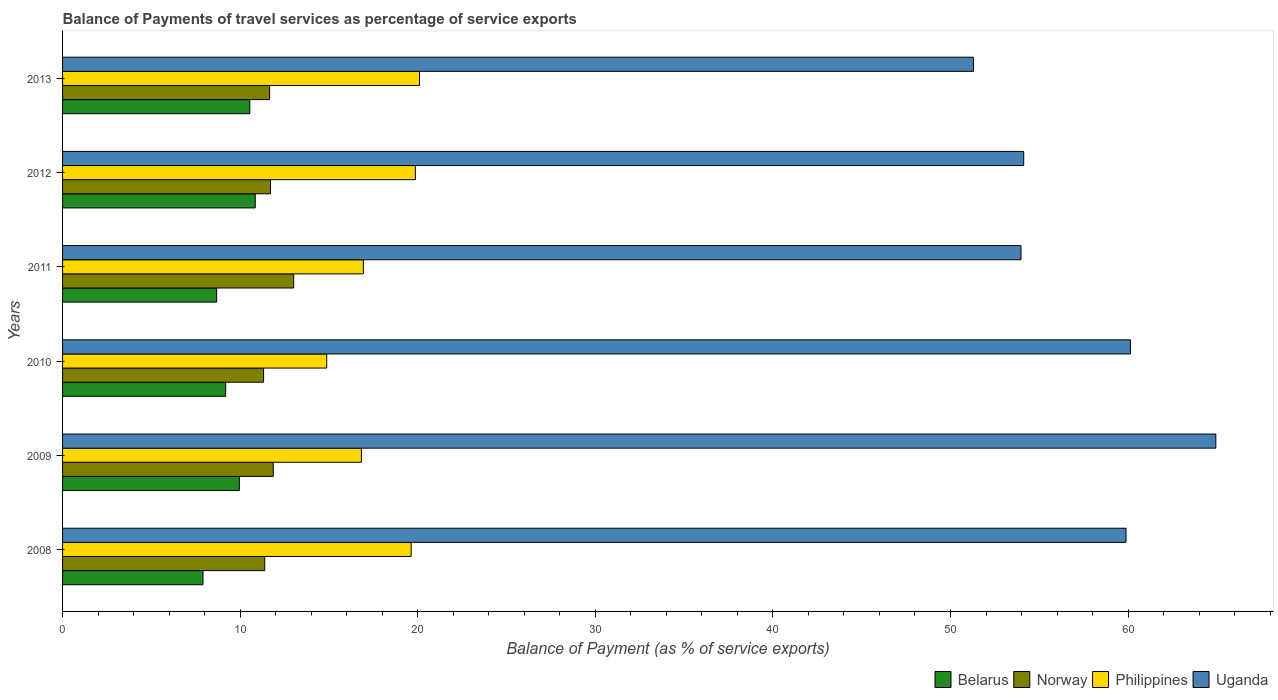Are the number of bars on each tick of the Y-axis equal?
Ensure brevity in your answer.  Yes. In how many cases, is the number of bars for a given year not equal to the number of legend labels?
Your answer should be compact. 0. What is the balance of payments of travel services in Belarus in 2012?
Keep it short and to the point. 10.85. Across all years, what is the maximum balance of payments of travel services in Uganda?
Offer a very short reply. 64.94. Across all years, what is the minimum balance of payments of travel services in Philippines?
Make the answer very short. 14.87. In which year was the balance of payments of travel services in Norway maximum?
Make the answer very short. 2011. In which year was the balance of payments of travel services in Uganda minimum?
Provide a succinct answer. 2013. What is the total balance of payments of travel services in Uganda in the graph?
Your answer should be compact. 344.34. What is the difference between the balance of payments of travel services in Uganda in 2008 and that in 2011?
Offer a terse response. 5.91. What is the difference between the balance of payments of travel services in Belarus in 2010 and the balance of payments of travel services in Norway in 2008?
Provide a succinct answer. -2.2. What is the average balance of payments of travel services in Belarus per year?
Your answer should be compact. 9.52. In the year 2011, what is the difference between the balance of payments of travel services in Norway and balance of payments of travel services in Uganda?
Make the answer very short. -40.96. In how many years, is the balance of payments of travel services in Belarus greater than 50 %?
Make the answer very short. 0. What is the ratio of the balance of payments of travel services in Philippines in 2008 to that in 2009?
Keep it short and to the point. 1.17. Is the difference between the balance of payments of travel services in Norway in 2011 and 2012 greater than the difference between the balance of payments of travel services in Uganda in 2011 and 2012?
Offer a terse response. Yes. What is the difference between the highest and the second highest balance of payments of travel services in Uganda?
Offer a very short reply. 4.81. What is the difference between the highest and the lowest balance of payments of travel services in Uganda?
Your response must be concise. 13.65. Is it the case that in every year, the sum of the balance of payments of travel services in Belarus and balance of payments of travel services in Norway is greater than the sum of balance of payments of travel services in Uganda and balance of payments of travel services in Philippines?
Your response must be concise. No. What does the 1st bar from the top in 2013 represents?
Ensure brevity in your answer.  Uganda. Is it the case that in every year, the sum of the balance of payments of travel services in Norway and balance of payments of travel services in Belarus is greater than the balance of payments of travel services in Uganda?
Give a very brief answer. No. Are all the bars in the graph horizontal?
Give a very brief answer. Yes. How many years are there in the graph?
Keep it short and to the point. 6. Does the graph contain any zero values?
Provide a succinct answer. No. How many legend labels are there?
Provide a succinct answer. 4. What is the title of the graph?
Make the answer very short. Balance of Payments of travel services as percentage of service exports. What is the label or title of the X-axis?
Make the answer very short. Balance of Payment (as % of service exports). What is the Balance of Payment (as % of service exports) of Belarus in 2008?
Your answer should be compact. 7.91. What is the Balance of Payment (as % of service exports) in Norway in 2008?
Provide a succinct answer. 11.38. What is the Balance of Payment (as % of service exports) of Philippines in 2008?
Ensure brevity in your answer.  19.63. What is the Balance of Payment (as % of service exports) in Uganda in 2008?
Make the answer very short. 59.88. What is the Balance of Payment (as % of service exports) in Belarus in 2009?
Ensure brevity in your answer.  9.95. What is the Balance of Payment (as % of service exports) of Norway in 2009?
Give a very brief answer. 11.86. What is the Balance of Payment (as % of service exports) in Philippines in 2009?
Give a very brief answer. 16.83. What is the Balance of Payment (as % of service exports) in Uganda in 2009?
Provide a succinct answer. 64.94. What is the Balance of Payment (as % of service exports) in Belarus in 2010?
Your answer should be compact. 9.18. What is the Balance of Payment (as % of service exports) of Norway in 2010?
Make the answer very short. 11.32. What is the Balance of Payment (as % of service exports) in Philippines in 2010?
Your answer should be compact. 14.87. What is the Balance of Payment (as % of service exports) of Uganda in 2010?
Give a very brief answer. 60.13. What is the Balance of Payment (as % of service exports) in Belarus in 2011?
Give a very brief answer. 8.68. What is the Balance of Payment (as % of service exports) of Norway in 2011?
Keep it short and to the point. 13.01. What is the Balance of Payment (as % of service exports) in Philippines in 2011?
Keep it short and to the point. 16.94. What is the Balance of Payment (as % of service exports) in Uganda in 2011?
Your response must be concise. 53.97. What is the Balance of Payment (as % of service exports) in Belarus in 2012?
Keep it short and to the point. 10.85. What is the Balance of Payment (as % of service exports) of Norway in 2012?
Your answer should be very brief. 11.71. What is the Balance of Payment (as % of service exports) in Philippines in 2012?
Provide a succinct answer. 19.87. What is the Balance of Payment (as % of service exports) of Uganda in 2012?
Your answer should be compact. 54.12. What is the Balance of Payment (as % of service exports) of Belarus in 2013?
Provide a succinct answer. 10.54. What is the Balance of Payment (as % of service exports) of Norway in 2013?
Provide a succinct answer. 11.66. What is the Balance of Payment (as % of service exports) in Philippines in 2013?
Keep it short and to the point. 20.1. What is the Balance of Payment (as % of service exports) of Uganda in 2013?
Give a very brief answer. 51.29. Across all years, what is the maximum Balance of Payment (as % of service exports) of Belarus?
Provide a short and direct response. 10.85. Across all years, what is the maximum Balance of Payment (as % of service exports) of Norway?
Your answer should be compact. 13.01. Across all years, what is the maximum Balance of Payment (as % of service exports) in Philippines?
Offer a very short reply. 20.1. Across all years, what is the maximum Balance of Payment (as % of service exports) in Uganda?
Your response must be concise. 64.94. Across all years, what is the minimum Balance of Payment (as % of service exports) of Belarus?
Provide a short and direct response. 7.91. Across all years, what is the minimum Balance of Payment (as % of service exports) of Norway?
Offer a terse response. 11.32. Across all years, what is the minimum Balance of Payment (as % of service exports) in Philippines?
Ensure brevity in your answer.  14.87. Across all years, what is the minimum Balance of Payment (as % of service exports) of Uganda?
Your answer should be compact. 51.29. What is the total Balance of Payment (as % of service exports) in Belarus in the graph?
Give a very brief answer. 57.11. What is the total Balance of Payment (as % of service exports) of Norway in the graph?
Your answer should be very brief. 70.95. What is the total Balance of Payment (as % of service exports) of Philippines in the graph?
Your answer should be compact. 108.23. What is the total Balance of Payment (as % of service exports) of Uganda in the graph?
Your answer should be compact. 344.34. What is the difference between the Balance of Payment (as % of service exports) of Belarus in 2008 and that in 2009?
Offer a terse response. -2.05. What is the difference between the Balance of Payment (as % of service exports) of Norway in 2008 and that in 2009?
Offer a very short reply. -0.48. What is the difference between the Balance of Payment (as % of service exports) in Philippines in 2008 and that in 2009?
Offer a terse response. 2.8. What is the difference between the Balance of Payment (as % of service exports) of Uganda in 2008 and that in 2009?
Your response must be concise. -5.06. What is the difference between the Balance of Payment (as % of service exports) in Belarus in 2008 and that in 2010?
Offer a terse response. -1.28. What is the difference between the Balance of Payment (as % of service exports) in Norway in 2008 and that in 2010?
Make the answer very short. 0.07. What is the difference between the Balance of Payment (as % of service exports) of Philippines in 2008 and that in 2010?
Provide a short and direct response. 4.75. What is the difference between the Balance of Payment (as % of service exports) of Uganda in 2008 and that in 2010?
Keep it short and to the point. -0.25. What is the difference between the Balance of Payment (as % of service exports) in Belarus in 2008 and that in 2011?
Keep it short and to the point. -0.77. What is the difference between the Balance of Payment (as % of service exports) of Norway in 2008 and that in 2011?
Keep it short and to the point. -1.63. What is the difference between the Balance of Payment (as % of service exports) of Philippines in 2008 and that in 2011?
Your response must be concise. 2.69. What is the difference between the Balance of Payment (as % of service exports) in Uganda in 2008 and that in 2011?
Keep it short and to the point. 5.91. What is the difference between the Balance of Payment (as % of service exports) of Belarus in 2008 and that in 2012?
Ensure brevity in your answer.  -2.94. What is the difference between the Balance of Payment (as % of service exports) of Norway in 2008 and that in 2012?
Ensure brevity in your answer.  -0.33. What is the difference between the Balance of Payment (as % of service exports) in Philippines in 2008 and that in 2012?
Provide a short and direct response. -0.24. What is the difference between the Balance of Payment (as % of service exports) in Uganda in 2008 and that in 2012?
Offer a terse response. 5.76. What is the difference between the Balance of Payment (as % of service exports) of Belarus in 2008 and that in 2013?
Ensure brevity in your answer.  -2.64. What is the difference between the Balance of Payment (as % of service exports) in Norway in 2008 and that in 2013?
Make the answer very short. -0.27. What is the difference between the Balance of Payment (as % of service exports) in Philippines in 2008 and that in 2013?
Your answer should be compact. -0.47. What is the difference between the Balance of Payment (as % of service exports) in Uganda in 2008 and that in 2013?
Your response must be concise. 8.59. What is the difference between the Balance of Payment (as % of service exports) in Belarus in 2009 and that in 2010?
Offer a terse response. 0.77. What is the difference between the Balance of Payment (as % of service exports) of Norway in 2009 and that in 2010?
Your answer should be compact. 0.54. What is the difference between the Balance of Payment (as % of service exports) in Philippines in 2009 and that in 2010?
Ensure brevity in your answer.  1.95. What is the difference between the Balance of Payment (as % of service exports) in Uganda in 2009 and that in 2010?
Your answer should be compact. 4.81. What is the difference between the Balance of Payment (as % of service exports) in Belarus in 2009 and that in 2011?
Your answer should be compact. 1.28. What is the difference between the Balance of Payment (as % of service exports) of Norway in 2009 and that in 2011?
Your response must be concise. -1.15. What is the difference between the Balance of Payment (as % of service exports) in Philippines in 2009 and that in 2011?
Give a very brief answer. -0.11. What is the difference between the Balance of Payment (as % of service exports) of Uganda in 2009 and that in 2011?
Give a very brief answer. 10.97. What is the difference between the Balance of Payment (as % of service exports) in Belarus in 2009 and that in 2012?
Make the answer very short. -0.89. What is the difference between the Balance of Payment (as % of service exports) of Norway in 2009 and that in 2012?
Keep it short and to the point. 0.15. What is the difference between the Balance of Payment (as % of service exports) of Philippines in 2009 and that in 2012?
Ensure brevity in your answer.  -3.04. What is the difference between the Balance of Payment (as % of service exports) in Uganda in 2009 and that in 2012?
Your answer should be compact. 10.82. What is the difference between the Balance of Payment (as % of service exports) of Belarus in 2009 and that in 2013?
Offer a very short reply. -0.59. What is the difference between the Balance of Payment (as % of service exports) in Norway in 2009 and that in 2013?
Keep it short and to the point. 0.2. What is the difference between the Balance of Payment (as % of service exports) of Philippines in 2009 and that in 2013?
Offer a terse response. -3.27. What is the difference between the Balance of Payment (as % of service exports) of Uganda in 2009 and that in 2013?
Provide a succinct answer. 13.65. What is the difference between the Balance of Payment (as % of service exports) in Belarus in 2010 and that in 2011?
Provide a succinct answer. 0.51. What is the difference between the Balance of Payment (as % of service exports) of Norway in 2010 and that in 2011?
Make the answer very short. -1.7. What is the difference between the Balance of Payment (as % of service exports) of Philippines in 2010 and that in 2011?
Keep it short and to the point. -2.06. What is the difference between the Balance of Payment (as % of service exports) in Uganda in 2010 and that in 2011?
Offer a very short reply. 6.16. What is the difference between the Balance of Payment (as % of service exports) in Belarus in 2010 and that in 2012?
Offer a terse response. -1.66. What is the difference between the Balance of Payment (as % of service exports) in Norway in 2010 and that in 2012?
Make the answer very short. -0.39. What is the difference between the Balance of Payment (as % of service exports) of Philippines in 2010 and that in 2012?
Keep it short and to the point. -4.99. What is the difference between the Balance of Payment (as % of service exports) in Uganda in 2010 and that in 2012?
Make the answer very short. 6.01. What is the difference between the Balance of Payment (as % of service exports) of Belarus in 2010 and that in 2013?
Offer a terse response. -1.36. What is the difference between the Balance of Payment (as % of service exports) of Norway in 2010 and that in 2013?
Provide a succinct answer. -0.34. What is the difference between the Balance of Payment (as % of service exports) in Philippines in 2010 and that in 2013?
Offer a very short reply. -5.22. What is the difference between the Balance of Payment (as % of service exports) in Uganda in 2010 and that in 2013?
Your answer should be compact. 8.84. What is the difference between the Balance of Payment (as % of service exports) in Belarus in 2011 and that in 2012?
Keep it short and to the point. -2.17. What is the difference between the Balance of Payment (as % of service exports) of Norway in 2011 and that in 2012?
Ensure brevity in your answer.  1.3. What is the difference between the Balance of Payment (as % of service exports) of Philippines in 2011 and that in 2012?
Make the answer very short. -2.93. What is the difference between the Balance of Payment (as % of service exports) of Uganda in 2011 and that in 2012?
Offer a very short reply. -0.15. What is the difference between the Balance of Payment (as % of service exports) in Belarus in 2011 and that in 2013?
Your answer should be compact. -1.87. What is the difference between the Balance of Payment (as % of service exports) in Norway in 2011 and that in 2013?
Your answer should be compact. 1.36. What is the difference between the Balance of Payment (as % of service exports) of Philippines in 2011 and that in 2013?
Keep it short and to the point. -3.16. What is the difference between the Balance of Payment (as % of service exports) of Uganda in 2011 and that in 2013?
Offer a very short reply. 2.68. What is the difference between the Balance of Payment (as % of service exports) of Belarus in 2012 and that in 2013?
Offer a terse response. 0.3. What is the difference between the Balance of Payment (as % of service exports) of Norway in 2012 and that in 2013?
Give a very brief answer. 0.05. What is the difference between the Balance of Payment (as % of service exports) in Philippines in 2012 and that in 2013?
Your response must be concise. -0.23. What is the difference between the Balance of Payment (as % of service exports) of Uganda in 2012 and that in 2013?
Provide a short and direct response. 2.83. What is the difference between the Balance of Payment (as % of service exports) of Belarus in 2008 and the Balance of Payment (as % of service exports) of Norway in 2009?
Offer a terse response. -3.96. What is the difference between the Balance of Payment (as % of service exports) in Belarus in 2008 and the Balance of Payment (as % of service exports) in Philippines in 2009?
Your response must be concise. -8.92. What is the difference between the Balance of Payment (as % of service exports) of Belarus in 2008 and the Balance of Payment (as % of service exports) of Uganda in 2009?
Your answer should be compact. -57.03. What is the difference between the Balance of Payment (as % of service exports) of Norway in 2008 and the Balance of Payment (as % of service exports) of Philippines in 2009?
Provide a succinct answer. -5.44. What is the difference between the Balance of Payment (as % of service exports) in Norway in 2008 and the Balance of Payment (as % of service exports) in Uganda in 2009?
Give a very brief answer. -53.56. What is the difference between the Balance of Payment (as % of service exports) in Philippines in 2008 and the Balance of Payment (as % of service exports) in Uganda in 2009?
Your response must be concise. -45.31. What is the difference between the Balance of Payment (as % of service exports) in Belarus in 2008 and the Balance of Payment (as % of service exports) in Norway in 2010?
Offer a very short reply. -3.41. What is the difference between the Balance of Payment (as % of service exports) in Belarus in 2008 and the Balance of Payment (as % of service exports) in Philippines in 2010?
Your response must be concise. -6.97. What is the difference between the Balance of Payment (as % of service exports) in Belarus in 2008 and the Balance of Payment (as % of service exports) in Uganda in 2010?
Give a very brief answer. -52.22. What is the difference between the Balance of Payment (as % of service exports) in Norway in 2008 and the Balance of Payment (as % of service exports) in Philippines in 2010?
Make the answer very short. -3.49. What is the difference between the Balance of Payment (as % of service exports) of Norway in 2008 and the Balance of Payment (as % of service exports) of Uganda in 2010?
Offer a terse response. -48.75. What is the difference between the Balance of Payment (as % of service exports) in Philippines in 2008 and the Balance of Payment (as % of service exports) in Uganda in 2010?
Provide a short and direct response. -40.5. What is the difference between the Balance of Payment (as % of service exports) of Belarus in 2008 and the Balance of Payment (as % of service exports) of Norway in 2011?
Your response must be concise. -5.11. What is the difference between the Balance of Payment (as % of service exports) in Belarus in 2008 and the Balance of Payment (as % of service exports) in Philippines in 2011?
Offer a terse response. -9.03. What is the difference between the Balance of Payment (as % of service exports) of Belarus in 2008 and the Balance of Payment (as % of service exports) of Uganda in 2011?
Provide a succinct answer. -46.06. What is the difference between the Balance of Payment (as % of service exports) in Norway in 2008 and the Balance of Payment (as % of service exports) in Philippines in 2011?
Keep it short and to the point. -5.55. What is the difference between the Balance of Payment (as % of service exports) of Norway in 2008 and the Balance of Payment (as % of service exports) of Uganda in 2011?
Your response must be concise. -42.59. What is the difference between the Balance of Payment (as % of service exports) in Philippines in 2008 and the Balance of Payment (as % of service exports) in Uganda in 2011?
Provide a succinct answer. -34.34. What is the difference between the Balance of Payment (as % of service exports) of Belarus in 2008 and the Balance of Payment (as % of service exports) of Norway in 2012?
Your answer should be very brief. -3.8. What is the difference between the Balance of Payment (as % of service exports) of Belarus in 2008 and the Balance of Payment (as % of service exports) of Philippines in 2012?
Offer a very short reply. -11.96. What is the difference between the Balance of Payment (as % of service exports) in Belarus in 2008 and the Balance of Payment (as % of service exports) in Uganda in 2012?
Your response must be concise. -46.22. What is the difference between the Balance of Payment (as % of service exports) in Norway in 2008 and the Balance of Payment (as % of service exports) in Philippines in 2012?
Provide a short and direct response. -8.48. What is the difference between the Balance of Payment (as % of service exports) in Norway in 2008 and the Balance of Payment (as % of service exports) in Uganda in 2012?
Your response must be concise. -42.74. What is the difference between the Balance of Payment (as % of service exports) of Philippines in 2008 and the Balance of Payment (as % of service exports) of Uganda in 2012?
Provide a short and direct response. -34.49. What is the difference between the Balance of Payment (as % of service exports) in Belarus in 2008 and the Balance of Payment (as % of service exports) in Norway in 2013?
Your answer should be very brief. -3.75. What is the difference between the Balance of Payment (as % of service exports) of Belarus in 2008 and the Balance of Payment (as % of service exports) of Philippines in 2013?
Your answer should be very brief. -12.19. What is the difference between the Balance of Payment (as % of service exports) of Belarus in 2008 and the Balance of Payment (as % of service exports) of Uganda in 2013?
Offer a very short reply. -43.38. What is the difference between the Balance of Payment (as % of service exports) of Norway in 2008 and the Balance of Payment (as % of service exports) of Philippines in 2013?
Make the answer very short. -8.71. What is the difference between the Balance of Payment (as % of service exports) of Norway in 2008 and the Balance of Payment (as % of service exports) of Uganda in 2013?
Offer a very short reply. -39.91. What is the difference between the Balance of Payment (as % of service exports) of Philippines in 2008 and the Balance of Payment (as % of service exports) of Uganda in 2013?
Provide a succinct answer. -31.66. What is the difference between the Balance of Payment (as % of service exports) in Belarus in 2009 and the Balance of Payment (as % of service exports) in Norway in 2010?
Your answer should be compact. -1.36. What is the difference between the Balance of Payment (as % of service exports) of Belarus in 2009 and the Balance of Payment (as % of service exports) of Philippines in 2010?
Provide a succinct answer. -4.92. What is the difference between the Balance of Payment (as % of service exports) in Belarus in 2009 and the Balance of Payment (as % of service exports) in Uganda in 2010?
Provide a succinct answer. -50.18. What is the difference between the Balance of Payment (as % of service exports) in Norway in 2009 and the Balance of Payment (as % of service exports) in Philippines in 2010?
Your answer should be compact. -3.01. What is the difference between the Balance of Payment (as % of service exports) in Norway in 2009 and the Balance of Payment (as % of service exports) in Uganda in 2010?
Make the answer very short. -48.27. What is the difference between the Balance of Payment (as % of service exports) in Philippines in 2009 and the Balance of Payment (as % of service exports) in Uganda in 2010?
Make the answer very short. -43.3. What is the difference between the Balance of Payment (as % of service exports) of Belarus in 2009 and the Balance of Payment (as % of service exports) of Norway in 2011?
Offer a very short reply. -3.06. What is the difference between the Balance of Payment (as % of service exports) in Belarus in 2009 and the Balance of Payment (as % of service exports) in Philippines in 2011?
Give a very brief answer. -6.98. What is the difference between the Balance of Payment (as % of service exports) of Belarus in 2009 and the Balance of Payment (as % of service exports) of Uganda in 2011?
Give a very brief answer. -44.02. What is the difference between the Balance of Payment (as % of service exports) of Norway in 2009 and the Balance of Payment (as % of service exports) of Philippines in 2011?
Give a very brief answer. -5.07. What is the difference between the Balance of Payment (as % of service exports) in Norway in 2009 and the Balance of Payment (as % of service exports) in Uganda in 2011?
Give a very brief answer. -42.11. What is the difference between the Balance of Payment (as % of service exports) in Philippines in 2009 and the Balance of Payment (as % of service exports) in Uganda in 2011?
Your answer should be very brief. -37.14. What is the difference between the Balance of Payment (as % of service exports) of Belarus in 2009 and the Balance of Payment (as % of service exports) of Norway in 2012?
Provide a short and direct response. -1.76. What is the difference between the Balance of Payment (as % of service exports) of Belarus in 2009 and the Balance of Payment (as % of service exports) of Philippines in 2012?
Ensure brevity in your answer.  -9.91. What is the difference between the Balance of Payment (as % of service exports) in Belarus in 2009 and the Balance of Payment (as % of service exports) in Uganda in 2012?
Offer a terse response. -44.17. What is the difference between the Balance of Payment (as % of service exports) of Norway in 2009 and the Balance of Payment (as % of service exports) of Philippines in 2012?
Ensure brevity in your answer.  -8. What is the difference between the Balance of Payment (as % of service exports) of Norway in 2009 and the Balance of Payment (as % of service exports) of Uganda in 2012?
Your response must be concise. -42.26. What is the difference between the Balance of Payment (as % of service exports) of Philippines in 2009 and the Balance of Payment (as % of service exports) of Uganda in 2012?
Your answer should be compact. -37.3. What is the difference between the Balance of Payment (as % of service exports) in Belarus in 2009 and the Balance of Payment (as % of service exports) in Norway in 2013?
Your response must be concise. -1.7. What is the difference between the Balance of Payment (as % of service exports) in Belarus in 2009 and the Balance of Payment (as % of service exports) in Philippines in 2013?
Ensure brevity in your answer.  -10.14. What is the difference between the Balance of Payment (as % of service exports) in Belarus in 2009 and the Balance of Payment (as % of service exports) in Uganda in 2013?
Provide a short and direct response. -41.34. What is the difference between the Balance of Payment (as % of service exports) of Norway in 2009 and the Balance of Payment (as % of service exports) of Philippines in 2013?
Make the answer very short. -8.23. What is the difference between the Balance of Payment (as % of service exports) of Norway in 2009 and the Balance of Payment (as % of service exports) of Uganda in 2013?
Provide a short and direct response. -39.43. What is the difference between the Balance of Payment (as % of service exports) of Philippines in 2009 and the Balance of Payment (as % of service exports) of Uganda in 2013?
Offer a terse response. -34.47. What is the difference between the Balance of Payment (as % of service exports) of Belarus in 2010 and the Balance of Payment (as % of service exports) of Norway in 2011?
Keep it short and to the point. -3.83. What is the difference between the Balance of Payment (as % of service exports) of Belarus in 2010 and the Balance of Payment (as % of service exports) of Philippines in 2011?
Ensure brevity in your answer.  -7.75. What is the difference between the Balance of Payment (as % of service exports) of Belarus in 2010 and the Balance of Payment (as % of service exports) of Uganda in 2011?
Make the answer very short. -44.79. What is the difference between the Balance of Payment (as % of service exports) in Norway in 2010 and the Balance of Payment (as % of service exports) in Philippines in 2011?
Ensure brevity in your answer.  -5.62. What is the difference between the Balance of Payment (as % of service exports) in Norway in 2010 and the Balance of Payment (as % of service exports) in Uganda in 2011?
Your response must be concise. -42.65. What is the difference between the Balance of Payment (as % of service exports) of Philippines in 2010 and the Balance of Payment (as % of service exports) of Uganda in 2011?
Provide a short and direct response. -39.1. What is the difference between the Balance of Payment (as % of service exports) in Belarus in 2010 and the Balance of Payment (as % of service exports) in Norway in 2012?
Give a very brief answer. -2.53. What is the difference between the Balance of Payment (as % of service exports) in Belarus in 2010 and the Balance of Payment (as % of service exports) in Philippines in 2012?
Offer a terse response. -10.68. What is the difference between the Balance of Payment (as % of service exports) in Belarus in 2010 and the Balance of Payment (as % of service exports) in Uganda in 2012?
Make the answer very short. -44.94. What is the difference between the Balance of Payment (as % of service exports) in Norway in 2010 and the Balance of Payment (as % of service exports) in Philippines in 2012?
Your response must be concise. -8.55. What is the difference between the Balance of Payment (as % of service exports) in Norway in 2010 and the Balance of Payment (as % of service exports) in Uganda in 2012?
Your answer should be compact. -42.8. What is the difference between the Balance of Payment (as % of service exports) of Philippines in 2010 and the Balance of Payment (as % of service exports) of Uganda in 2012?
Your answer should be compact. -39.25. What is the difference between the Balance of Payment (as % of service exports) of Belarus in 2010 and the Balance of Payment (as % of service exports) of Norway in 2013?
Keep it short and to the point. -2.48. What is the difference between the Balance of Payment (as % of service exports) of Belarus in 2010 and the Balance of Payment (as % of service exports) of Philippines in 2013?
Provide a short and direct response. -10.91. What is the difference between the Balance of Payment (as % of service exports) in Belarus in 2010 and the Balance of Payment (as % of service exports) in Uganda in 2013?
Offer a terse response. -42.11. What is the difference between the Balance of Payment (as % of service exports) of Norway in 2010 and the Balance of Payment (as % of service exports) of Philippines in 2013?
Offer a terse response. -8.78. What is the difference between the Balance of Payment (as % of service exports) in Norway in 2010 and the Balance of Payment (as % of service exports) in Uganda in 2013?
Give a very brief answer. -39.97. What is the difference between the Balance of Payment (as % of service exports) of Philippines in 2010 and the Balance of Payment (as % of service exports) of Uganda in 2013?
Offer a terse response. -36.42. What is the difference between the Balance of Payment (as % of service exports) of Belarus in 2011 and the Balance of Payment (as % of service exports) of Norway in 2012?
Offer a very short reply. -3.03. What is the difference between the Balance of Payment (as % of service exports) of Belarus in 2011 and the Balance of Payment (as % of service exports) of Philippines in 2012?
Provide a succinct answer. -11.19. What is the difference between the Balance of Payment (as % of service exports) in Belarus in 2011 and the Balance of Payment (as % of service exports) in Uganda in 2012?
Your answer should be compact. -45.45. What is the difference between the Balance of Payment (as % of service exports) in Norway in 2011 and the Balance of Payment (as % of service exports) in Philippines in 2012?
Provide a short and direct response. -6.85. What is the difference between the Balance of Payment (as % of service exports) in Norway in 2011 and the Balance of Payment (as % of service exports) in Uganda in 2012?
Make the answer very short. -41.11. What is the difference between the Balance of Payment (as % of service exports) of Philippines in 2011 and the Balance of Payment (as % of service exports) of Uganda in 2012?
Offer a very short reply. -37.18. What is the difference between the Balance of Payment (as % of service exports) in Belarus in 2011 and the Balance of Payment (as % of service exports) in Norway in 2013?
Your answer should be compact. -2.98. What is the difference between the Balance of Payment (as % of service exports) in Belarus in 2011 and the Balance of Payment (as % of service exports) in Philippines in 2013?
Make the answer very short. -11.42. What is the difference between the Balance of Payment (as % of service exports) of Belarus in 2011 and the Balance of Payment (as % of service exports) of Uganda in 2013?
Give a very brief answer. -42.62. What is the difference between the Balance of Payment (as % of service exports) in Norway in 2011 and the Balance of Payment (as % of service exports) in Philippines in 2013?
Provide a short and direct response. -7.08. What is the difference between the Balance of Payment (as % of service exports) of Norway in 2011 and the Balance of Payment (as % of service exports) of Uganda in 2013?
Offer a terse response. -38.28. What is the difference between the Balance of Payment (as % of service exports) in Philippines in 2011 and the Balance of Payment (as % of service exports) in Uganda in 2013?
Offer a very short reply. -34.35. What is the difference between the Balance of Payment (as % of service exports) in Belarus in 2012 and the Balance of Payment (as % of service exports) in Norway in 2013?
Ensure brevity in your answer.  -0.81. What is the difference between the Balance of Payment (as % of service exports) in Belarus in 2012 and the Balance of Payment (as % of service exports) in Philippines in 2013?
Your answer should be very brief. -9.25. What is the difference between the Balance of Payment (as % of service exports) in Belarus in 2012 and the Balance of Payment (as % of service exports) in Uganda in 2013?
Provide a succinct answer. -40.44. What is the difference between the Balance of Payment (as % of service exports) in Norway in 2012 and the Balance of Payment (as % of service exports) in Philippines in 2013?
Your answer should be compact. -8.39. What is the difference between the Balance of Payment (as % of service exports) of Norway in 2012 and the Balance of Payment (as % of service exports) of Uganda in 2013?
Offer a very short reply. -39.58. What is the difference between the Balance of Payment (as % of service exports) of Philippines in 2012 and the Balance of Payment (as % of service exports) of Uganda in 2013?
Ensure brevity in your answer.  -31.43. What is the average Balance of Payment (as % of service exports) of Belarus per year?
Give a very brief answer. 9.52. What is the average Balance of Payment (as % of service exports) of Norway per year?
Keep it short and to the point. 11.83. What is the average Balance of Payment (as % of service exports) in Philippines per year?
Your answer should be compact. 18.04. What is the average Balance of Payment (as % of service exports) in Uganda per year?
Offer a terse response. 57.39. In the year 2008, what is the difference between the Balance of Payment (as % of service exports) of Belarus and Balance of Payment (as % of service exports) of Norway?
Your response must be concise. -3.48. In the year 2008, what is the difference between the Balance of Payment (as % of service exports) of Belarus and Balance of Payment (as % of service exports) of Philippines?
Provide a short and direct response. -11.72. In the year 2008, what is the difference between the Balance of Payment (as % of service exports) in Belarus and Balance of Payment (as % of service exports) in Uganda?
Your answer should be compact. -51.98. In the year 2008, what is the difference between the Balance of Payment (as % of service exports) of Norway and Balance of Payment (as % of service exports) of Philippines?
Your response must be concise. -8.25. In the year 2008, what is the difference between the Balance of Payment (as % of service exports) in Norway and Balance of Payment (as % of service exports) in Uganda?
Offer a very short reply. -48.5. In the year 2008, what is the difference between the Balance of Payment (as % of service exports) of Philippines and Balance of Payment (as % of service exports) of Uganda?
Give a very brief answer. -40.25. In the year 2009, what is the difference between the Balance of Payment (as % of service exports) of Belarus and Balance of Payment (as % of service exports) of Norway?
Your answer should be very brief. -1.91. In the year 2009, what is the difference between the Balance of Payment (as % of service exports) of Belarus and Balance of Payment (as % of service exports) of Philippines?
Your answer should be compact. -6.87. In the year 2009, what is the difference between the Balance of Payment (as % of service exports) in Belarus and Balance of Payment (as % of service exports) in Uganda?
Offer a very short reply. -54.99. In the year 2009, what is the difference between the Balance of Payment (as % of service exports) of Norway and Balance of Payment (as % of service exports) of Philippines?
Offer a very short reply. -4.96. In the year 2009, what is the difference between the Balance of Payment (as % of service exports) of Norway and Balance of Payment (as % of service exports) of Uganda?
Provide a succinct answer. -53.08. In the year 2009, what is the difference between the Balance of Payment (as % of service exports) in Philippines and Balance of Payment (as % of service exports) in Uganda?
Keep it short and to the point. -48.11. In the year 2010, what is the difference between the Balance of Payment (as % of service exports) in Belarus and Balance of Payment (as % of service exports) in Norway?
Your answer should be compact. -2.14. In the year 2010, what is the difference between the Balance of Payment (as % of service exports) of Belarus and Balance of Payment (as % of service exports) of Philippines?
Your response must be concise. -5.69. In the year 2010, what is the difference between the Balance of Payment (as % of service exports) in Belarus and Balance of Payment (as % of service exports) in Uganda?
Your answer should be very brief. -50.95. In the year 2010, what is the difference between the Balance of Payment (as % of service exports) of Norway and Balance of Payment (as % of service exports) of Philippines?
Your answer should be compact. -3.56. In the year 2010, what is the difference between the Balance of Payment (as % of service exports) in Norway and Balance of Payment (as % of service exports) in Uganda?
Ensure brevity in your answer.  -48.81. In the year 2010, what is the difference between the Balance of Payment (as % of service exports) of Philippines and Balance of Payment (as % of service exports) of Uganda?
Your answer should be very brief. -45.26. In the year 2011, what is the difference between the Balance of Payment (as % of service exports) of Belarus and Balance of Payment (as % of service exports) of Norway?
Give a very brief answer. -4.34. In the year 2011, what is the difference between the Balance of Payment (as % of service exports) in Belarus and Balance of Payment (as % of service exports) in Philippines?
Your answer should be compact. -8.26. In the year 2011, what is the difference between the Balance of Payment (as % of service exports) in Belarus and Balance of Payment (as % of service exports) in Uganda?
Your answer should be very brief. -45.29. In the year 2011, what is the difference between the Balance of Payment (as % of service exports) in Norway and Balance of Payment (as % of service exports) in Philippines?
Make the answer very short. -3.92. In the year 2011, what is the difference between the Balance of Payment (as % of service exports) in Norway and Balance of Payment (as % of service exports) in Uganda?
Make the answer very short. -40.96. In the year 2011, what is the difference between the Balance of Payment (as % of service exports) of Philippines and Balance of Payment (as % of service exports) of Uganda?
Keep it short and to the point. -37.03. In the year 2012, what is the difference between the Balance of Payment (as % of service exports) in Belarus and Balance of Payment (as % of service exports) in Norway?
Ensure brevity in your answer.  -0.86. In the year 2012, what is the difference between the Balance of Payment (as % of service exports) of Belarus and Balance of Payment (as % of service exports) of Philippines?
Provide a short and direct response. -9.02. In the year 2012, what is the difference between the Balance of Payment (as % of service exports) of Belarus and Balance of Payment (as % of service exports) of Uganda?
Provide a succinct answer. -43.27. In the year 2012, what is the difference between the Balance of Payment (as % of service exports) in Norway and Balance of Payment (as % of service exports) in Philippines?
Your response must be concise. -8.16. In the year 2012, what is the difference between the Balance of Payment (as % of service exports) of Norway and Balance of Payment (as % of service exports) of Uganda?
Keep it short and to the point. -42.41. In the year 2012, what is the difference between the Balance of Payment (as % of service exports) of Philippines and Balance of Payment (as % of service exports) of Uganda?
Ensure brevity in your answer.  -34.26. In the year 2013, what is the difference between the Balance of Payment (as % of service exports) in Belarus and Balance of Payment (as % of service exports) in Norway?
Provide a succinct answer. -1.12. In the year 2013, what is the difference between the Balance of Payment (as % of service exports) in Belarus and Balance of Payment (as % of service exports) in Philippines?
Make the answer very short. -9.55. In the year 2013, what is the difference between the Balance of Payment (as % of service exports) in Belarus and Balance of Payment (as % of service exports) in Uganda?
Your response must be concise. -40.75. In the year 2013, what is the difference between the Balance of Payment (as % of service exports) of Norway and Balance of Payment (as % of service exports) of Philippines?
Make the answer very short. -8.44. In the year 2013, what is the difference between the Balance of Payment (as % of service exports) of Norway and Balance of Payment (as % of service exports) of Uganda?
Make the answer very short. -39.63. In the year 2013, what is the difference between the Balance of Payment (as % of service exports) in Philippines and Balance of Payment (as % of service exports) in Uganda?
Ensure brevity in your answer.  -31.19. What is the ratio of the Balance of Payment (as % of service exports) in Belarus in 2008 to that in 2009?
Provide a short and direct response. 0.79. What is the ratio of the Balance of Payment (as % of service exports) of Norway in 2008 to that in 2009?
Provide a succinct answer. 0.96. What is the ratio of the Balance of Payment (as % of service exports) in Philippines in 2008 to that in 2009?
Provide a short and direct response. 1.17. What is the ratio of the Balance of Payment (as % of service exports) in Uganda in 2008 to that in 2009?
Ensure brevity in your answer.  0.92. What is the ratio of the Balance of Payment (as % of service exports) of Belarus in 2008 to that in 2010?
Keep it short and to the point. 0.86. What is the ratio of the Balance of Payment (as % of service exports) in Philippines in 2008 to that in 2010?
Offer a very short reply. 1.32. What is the ratio of the Balance of Payment (as % of service exports) of Belarus in 2008 to that in 2011?
Your answer should be compact. 0.91. What is the ratio of the Balance of Payment (as % of service exports) in Norway in 2008 to that in 2011?
Provide a succinct answer. 0.87. What is the ratio of the Balance of Payment (as % of service exports) of Philippines in 2008 to that in 2011?
Keep it short and to the point. 1.16. What is the ratio of the Balance of Payment (as % of service exports) of Uganda in 2008 to that in 2011?
Your response must be concise. 1.11. What is the ratio of the Balance of Payment (as % of service exports) in Belarus in 2008 to that in 2012?
Provide a succinct answer. 0.73. What is the ratio of the Balance of Payment (as % of service exports) in Norway in 2008 to that in 2012?
Offer a very short reply. 0.97. What is the ratio of the Balance of Payment (as % of service exports) of Uganda in 2008 to that in 2012?
Offer a very short reply. 1.11. What is the ratio of the Balance of Payment (as % of service exports) of Belarus in 2008 to that in 2013?
Make the answer very short. 0.75. What is the ratio of the Balance of Payment (as % of service exports) of Norway in 2008 to that in 2013?
Offer a terse response. 0.98. What is the ratio of the Balance of Payment (as % of service exports) of Philippines in 2008 to that in 2013?
Your answer should be very brief. 0.98. What is the ratio of the Balance of Payment (as % of service exports) of Uganda in 2008 to that in 2013?
Offer a terse response. 1.17. What is the ratio of the Balance of Payment (as % of service exports) of Belarus in 2009 to that in 2010?
Keep it short and to the point. 1.08. What is the ratio of the Balance of Payment (as % of service exports) in Norway in 2009 to that in 2010?
Keep it short and to the point. 1.05. What is the ratio of the Balance of Payment (as % of service exports) in Philippines in 2009 to that in 2010?
Make the answer very short. 1.13. What is the ratio of the Balance of Payment (as % of service exports) of Belarus in 2009 to that in 2011?
Offer a very short reply. 1.15. What is the ratio of the Balance of Payment (as % of service exports) of Norway in 2009 to that in 2011?
Give a very brief answer. 0.91. What is the ratio of the Balance of Payment (as % of service exports) of Philippines in 2009 to that in 2011?
Offer a very short reply. 0.99. What is the ratio of the Balance of Payment (as % of service exports) in Uganda in 2009 to that in 2011?
Offer a very short reply. 1.2. What is the ratio of the Balance of Payment (as % of service exports) of Belarus in 2009 to that in 2012?
Ensure brevity in your answer.  0.92. What is the ratio of the Balance of Payment (as % of service exports) in Norway in 2009 to that in 2012?
Keep it short and to the point. 1.01. What is the ratio of the Balance of Payment (as % of service exports) of Philippines in 2009 to that in 2012?
Your answer should be very brief. 0.85. What is the ratio of the Balance of Payment (as % of service exports) of Uganda in 2009 to that in 2012?
Your answer should be compact. 1.2. What is the ratio of the Balance of Payment (as % of service exports) of Belarus in 2009 to that in 2013?
Offer a terse response. 0.94. What is the ratio of the Balance of Payment (as % of service exports) of Norway in 2009 to that in 2013?
Ensure brevity in your answer.  1.02. What is the ratio of the Balance of Payment (as % of service exports) of Philippines in 2009 to that in 2013?
Provide a succinct answer. 0.84. What is the ratio of the Balance of Payment (as % of service exports) of Uganda in 2009 to that in 2013?
Offer a terse response. 1.27. What is the ratio of the Balance of Payment (as % of service exports) of Belarus in 2010 to that in 2011?
Your answer should be compact. 1.06. What is the ratio of the Balance of Payment (as % of service exports) of Norway in 2010 to that in 2011?
Your answer should be compact. 0.87. What is the ratio of the Balance of Payment (as % of service exports) in Philippines in 2010 to that in 2011?
Provide a succinct answer. 0.88. What is the ratio of the Balance of Payment (as % of service exports) in Uganda in 2010 to that in 2011?
Give a very brief answer. 1.11. What is the ratio of the Balance of Payment (as % of service exports) in Belarus in 2010 to that in 2012?
Offer a terse response. 0.85. What is the ratio of the Balance of Payment (as % of service exports) of Norway in 2010 to that in 2012?
Your response must be concise. 0.97. What is the ratio of the Balance of Payment (as % of service exports) in Philippines in 2010 to that in 2012?
Your response must be concise. 0.75. What is the ratio of the Balance of Payment (as % of service exports) of Uganda in 2010 to that in 2012?
Ensure brevity in your answer.  1.11. What is the ratio of the Balance of Payment (as % of service exports) of Belarus in 2010 to that in 2013?
Keep it short and to the point. 0.87. What is the ratio of the Balance of Payment (as % of service exports) in Norway in 2010 to that in 2013?
Make the answer very short. 0.97. What is the ratio of the Balance of Payment (as % of service exports) in Philippines in 2010 to that in 2013?
Offer a terse response. 0.74. What is the ratio of the Balance of Payment (as % of service exports) of Uganda in 2010 to that in 2013?
Offer a terse response. 1.17. What is the ratio of the Balance of Payment (as % of service exports) in Belarus in 2011 to that in 2012?
Make the answer very short. 0.8. What is the ratio of the Balance of Payment (as % of service exports) in Norway in 2011 to that in 2012?
Give a very brief answer. 1.11. What is the ratio of the Balance of Payment (as % of service exports) of Philippines in 2011 to that in 2012?
Provide a short and direct response. 0.85. What is the ratio of the Balance of Payment (as % of service exports) in Uganda in 2011 to that in 2012?
Provide a succinct answer. 1. What is the ratio of the Balance of Payment (as % of service exports) in Belarus in 2011 to that in 2013?
Make the answer very short. 0.82. What is the ratio of the Balance of Payment (as % of service exports) of Norway in 2011 to that in 2013?
Make the answer very short. 1.12. What is the ratio of the Balance of Payment (as % of service exports) in Philippines in 2011 to that in 2013?
Your response must be concise. 0.84. What is the ratio of the Balance of Payment (as % of service exports) in Uganda in 2011 to that in 2013?
Offer a very short reply. 1.05. What is the ratio of the Balance of Payment (as % of service exports) of Belarus in 2012 to that in 2013?
Make the answer very short. 1.03. What is the ratio of the Balance of Payment (as % of service exports) of Norway in 2012 to that in 2013?
Keep it short and to the point. 1. What is the ratio of the Balance of Payment (as % of service exports) in Philippines in 2012 to that in 2013?
Your response must be concise. 0.99. What is the ratio of the Balance of Payment (as % of service exports) in Uganda in 2012 to that in 2013?
Provide a short and direct response. 1.06. What is the difference between the highest and the second highest Balance of Payment (as % of service exports) of Belarus?
Provide a short and direct response. 0.3. What is the difference between the highest and the second highest Balance of Payment (as % of service exports) of Norway?
Make the answer very short. 1.15. What is the difference between the highest and the second highest Balance of Payment (as % of service exports) of Philippines?
Give a very brief answer. 0.23. What is the difference between the highest and the second highest Balance of Payment (as % of service exports) of Uganda?
Give a very brief answer. 4.81. What is the difference between the highest and the lowest Balance of Payment (as % of service exports) of Belarus?
Your answer should be compact. 2.94. What is the difference between the highest and the lowest Balance of Payment (as % of service exports) in Norway?
Offer a terse response. 1.7. What is the difference between the highest and the lowest Balance of Payment (as % of service exports) of Philippines?
Provide a succinct answer. 5.22. What is the difference between the highest and the lowest Balance of Payment (as % of service exports) in Uganda?
Provide a succinct answer. 13.65. 